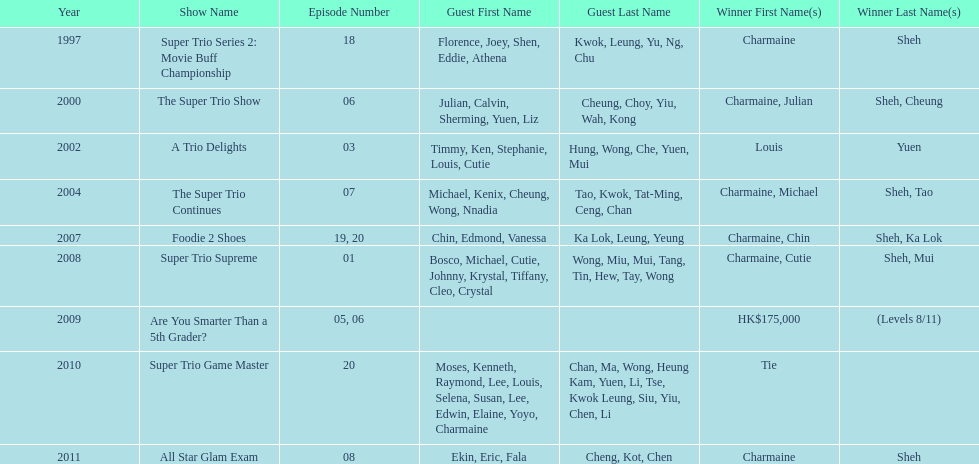How many of shows had at least 5 episodes? 7. 